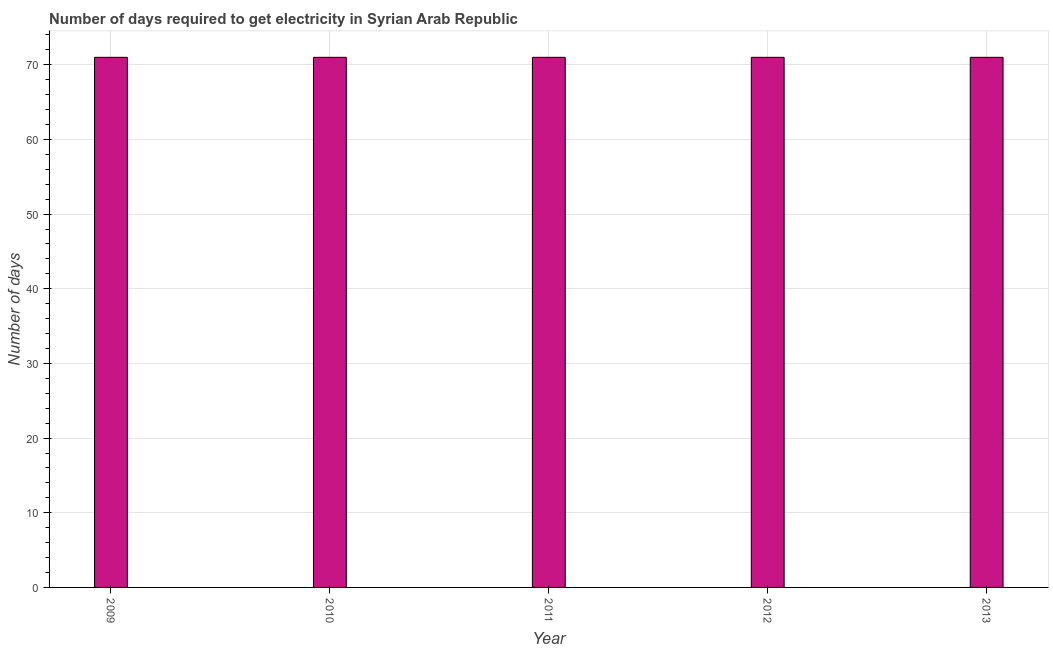Does the graph contain any zero values?
Your answer should be very brief. No. Does the graph contain grids?
Ensure brevity in your answer.  Yes. What is the title of the graph?
Offer a very short reply. Number of days required to get electricity in Syrian Arab Republic. What is the label or title of the X-axis?
Provide a short and direct response. Year. What is the label or title of the Y-axis?
Provide a short and direct response. Number of days. In which year was the time to get electricity maximum?
Your answer should be compact. 2009. In which year was the time to get electricity minimum?
Ensure brevity in your answer.  2009. What is the sum of the time to get electricity?
Your response must be concise. 355. What is the average time to get electricity per year?
Make the answer very short. 71. In how many years, is the time to get electricity greater than 26 ?
Ensure brevity in your answer.  5. Do a majority of the years between 2009 and 2013 (inclusive) have time to get electricity greater than 72 ?
Offer a very short reply. No. Is the time to get electricity in 2012 less than that in 2013?
Your answer should be compact. No. What is the difference between the highest and the lowest time to get electricity?
Your answer should be compact. 0. How many bars are there?
Your response must be concise. 5. How many years are there in the graph?
Offer a very short reply. 5. What is the difference between two consecutive major ticks on the Y-axis?
Offer a very short reply. 10. Are the values on the major ticks of Y-axis written in scientific E-notation?
Offer a terse response. No. What is the Number of days of 2011?
Offer a very short reply. 71. What is the difference between the Number of days in 2009 and 2010?
Provide a succinct answer. 0. What is the difference between the Number of days in 2009 and 2011?
Make the answer very short. 0. What is the difference between the Number of days in 2009 and 2012?
Ensure brevity in your answer.  0. What is the difference between the Number of days in 2010 and 2012?
Make the answer very short. 0. What is the difference between the Number of days in 2010 and 2013?
Offer a terse response. 0. What is the difference between the Number of days in 2011 and 2013?
Your answer should be very brief. 0. What is the ratio of the Number of days in 2009 to that in 2011?
Keep it short and to the point. 1. What is the ratio of the Number of days in 2009 to that in 2012?
Offer a very short reply. 1. What is the ratio of the Number of days in 2009 to that in 2013?
Keep it short and to the point. 1. What is the ratio of the Number of days in 2010 to that in 2013?
Give a very brief answer. 1. What is the ratio of the Number of days in 2011 to that in 2013?
Your answer should be very brief. 1. What is the ratio of the Number of days in 2012 to that in 2013?
Provide a succinct answer. 1. 